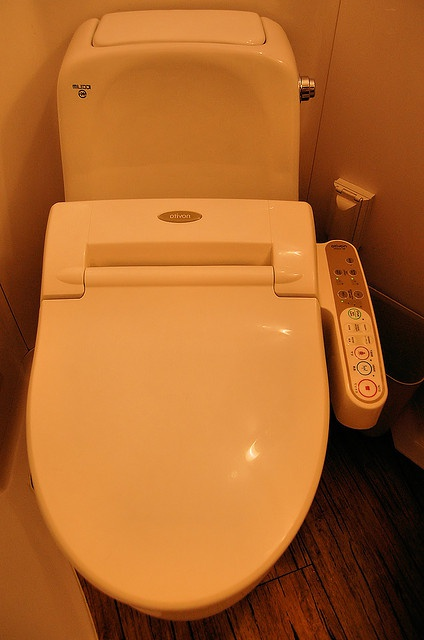Describe the objects in this image and their specific colors. I can see a toilet in orange and red tones in this image. 